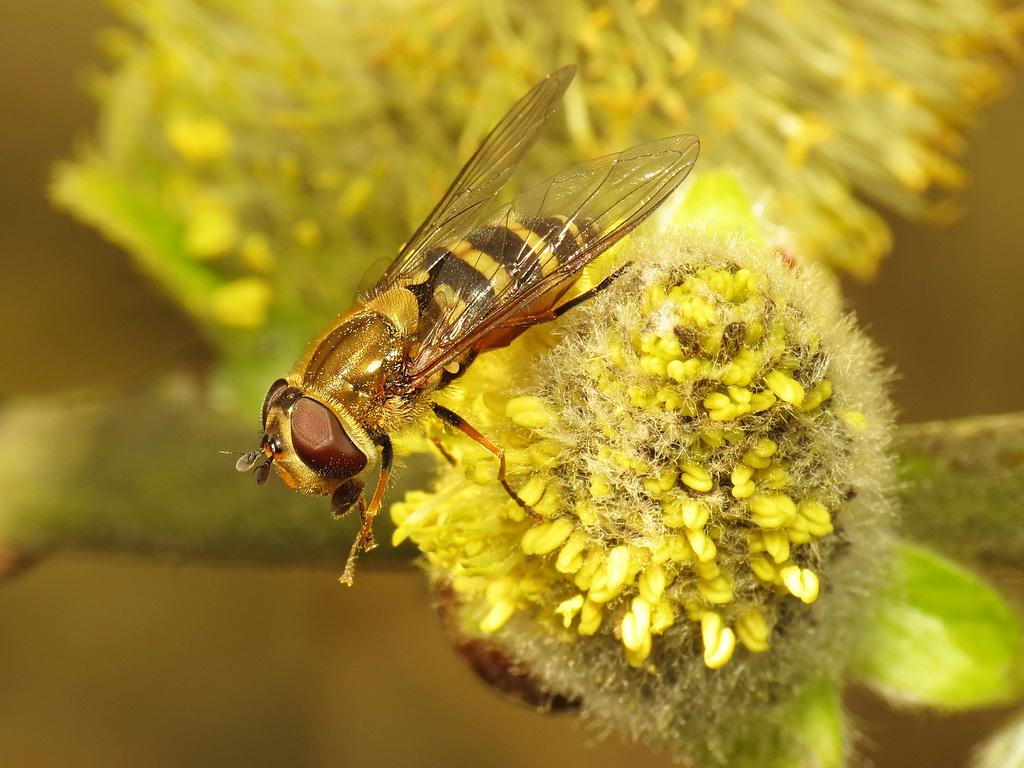What type of insect is in the image? There is a honey bee in the image. What is the honey bee doing in the image? The honey bee is on a yellow flower. Where is the flower located in the image? The flower is in the middle of the image. What type of jeans is the honey bee wearing in the image? Honey bees do not wear jeans, as they are insects and do not have the ability to wear clothing. 